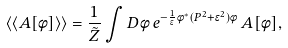Convert formula to latex. <formula><loc_0><loc_0><loc_500><loc_500>\langle \langle A [ \phi ] \rangle \rangle = \frac { 1 } { \tilde { Z } } \int D \phi \, e ^ { - \frac { 1 } { \epsilon } \phi ^ { * } ( P ^ { 2 } + \epsilon ^ { 2 } ) \phi } \, A [ \phi ] ,</formula> 